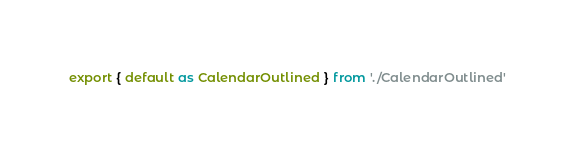Convert code to text. <code><loc_0><loc_0><loc_500><loc_500><_JavaScript_>export { default as CalendarOutlined } from './CalendarOutlined'</code> 